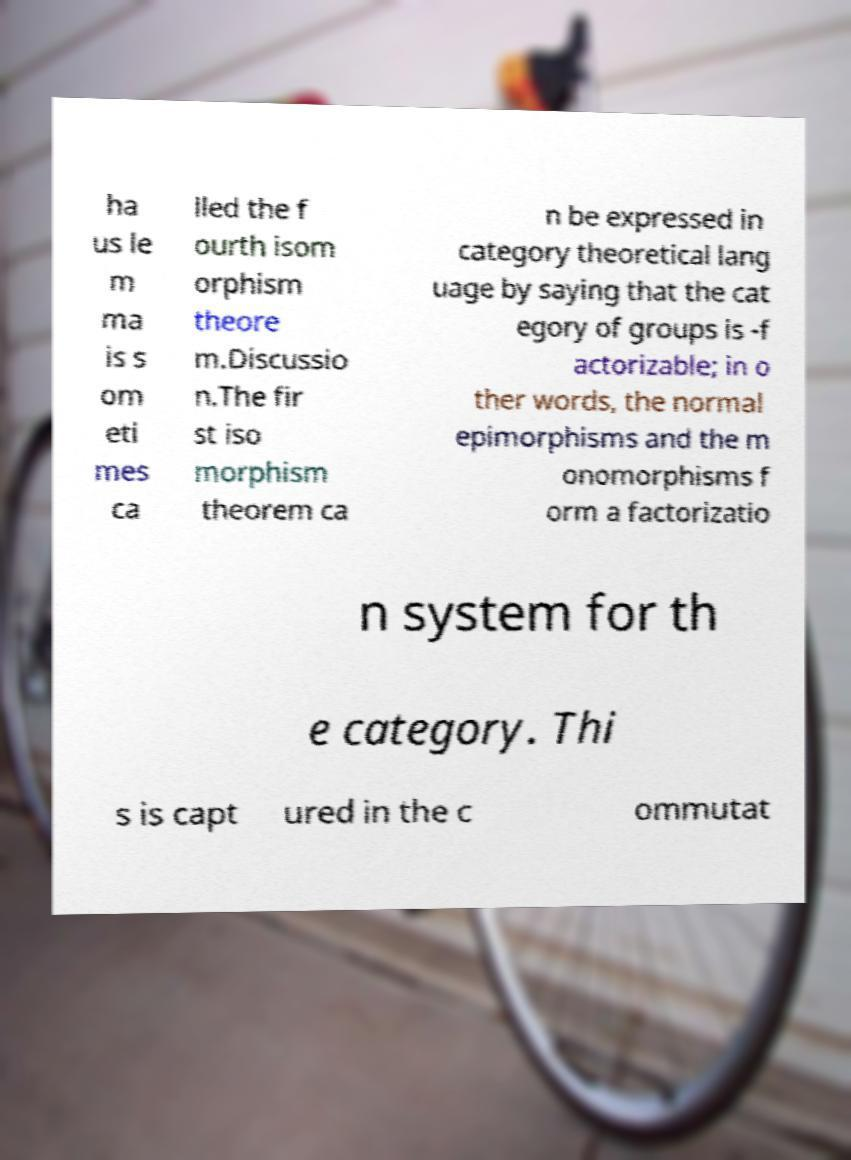Could you extract and type out the text from this image? ha us le m ma is s om eti mes ca lled the f ourth isom orphism theore m.Discussio n.The fir st iso morphism theorem ca n be expressed in category theoretical lang uage by saying that the cat egory of groups is -f actorizable; in o ther words, the normal epimorphisms and the m onomorphisms f orm a factorizatio n system for th e category. Thi s is capt ured in the c ommutat 